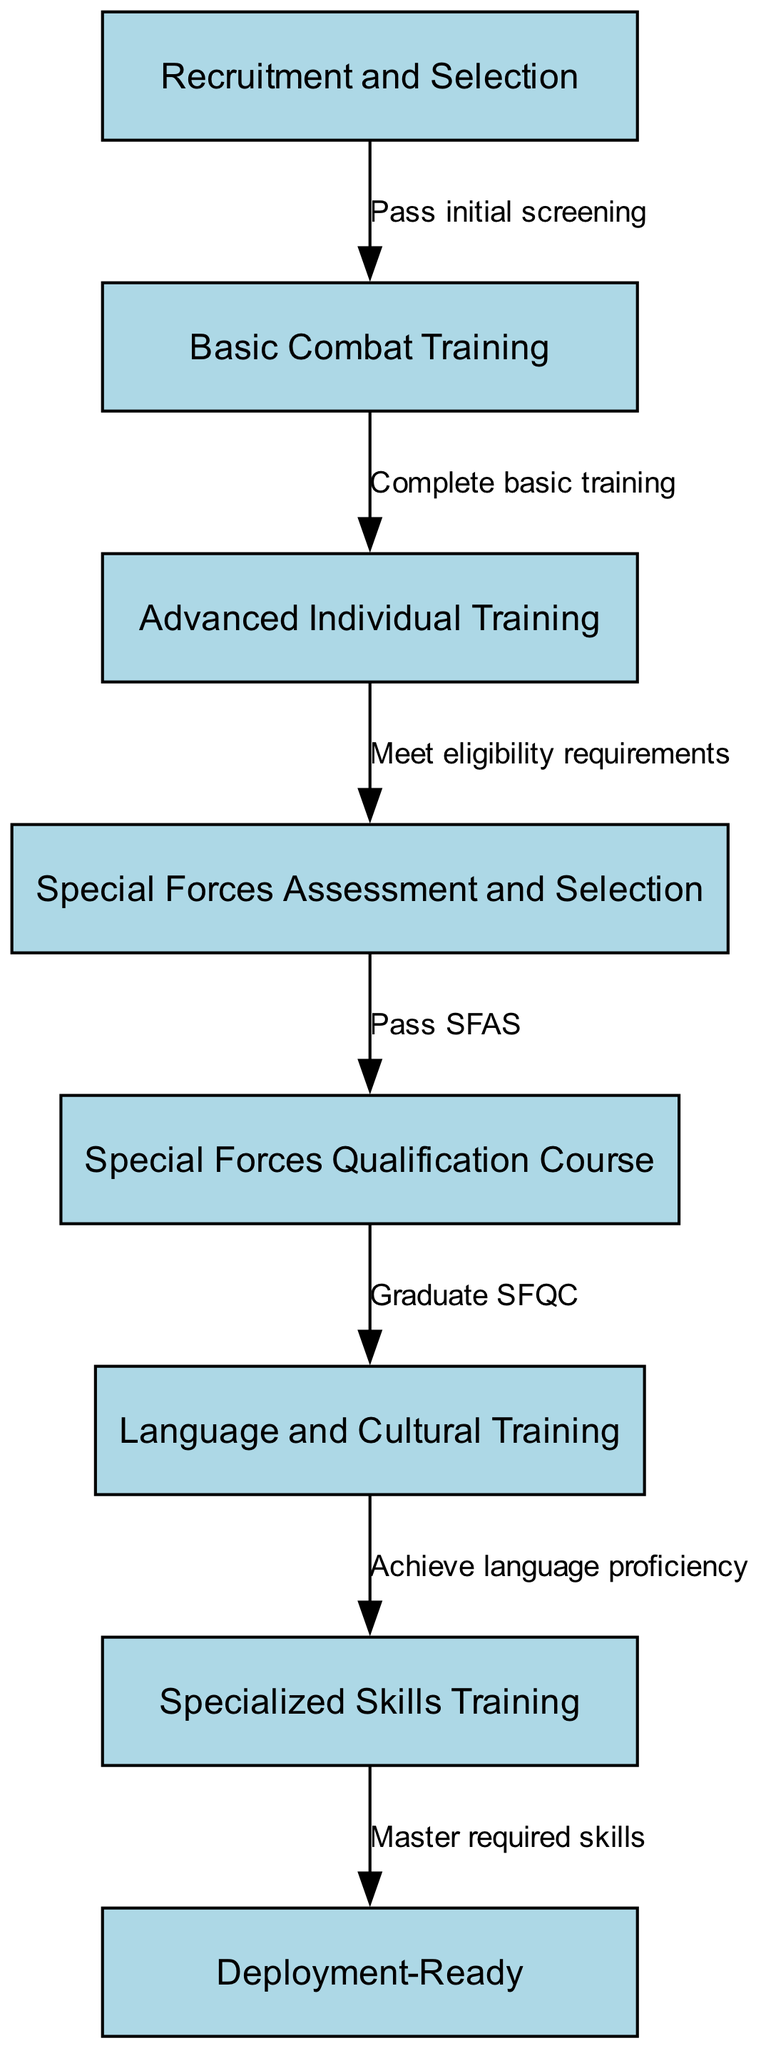What is the first stage of the training program? The first stage is "Recruitment and Selection," as indicated by the first node in the diagram.
Answer: Recruitment and Selection How many stages are in the training program? There are eight stages total, which are reflected in the eight nodes that make up the flowchart.
Answer: 8 What does one need to do to move from Basic Combat Training to Advanced Individual Training? To move from "Basic Combat Training" to "Advanced Individual Training," one must "Complete basic training," as shown on the connecting edge.
Answer: Complete basic training Which stage comes after the Special Forces Assessment and Selection? The stage that comes after "Special Forces Assessment and Selection" is the "Special Forces Qualification Course," as illustrated by the directed edge leading to it.
Answer: Special Forces Qualification Course What are the two outcomes after completing the Specialized Skills Training? After completing "Specialized Skills Training," the outcome is being "Deployment-Ready," which denotes readiness for deployment as indicated by the final node in the flowchart.
Answer: Deployment-Ready What is the prerequisite for entering the Special Forces Qualification Course? The prerequisite for entering the "Special Forces Qualification Course" is to "Pass SFAS," which is specified as the connection from the "Special Forces Assessment and Selection" stage.
Answer: Pass SFAS What is required before achieving language proficiency? Before achieving language proficiency, one must "Graduate SFQC," as depicted in the diagram where the edge denotes the need to graduate prior to language training.
Answer: Graduate SFQC What type of training occurs after language and cultural training? After "Language and Cultural Training," the type of training that occurs is "Specialized Skills Training," as shown by the directed flow from one stage to the next.
Answer: Specialized Skills Training 